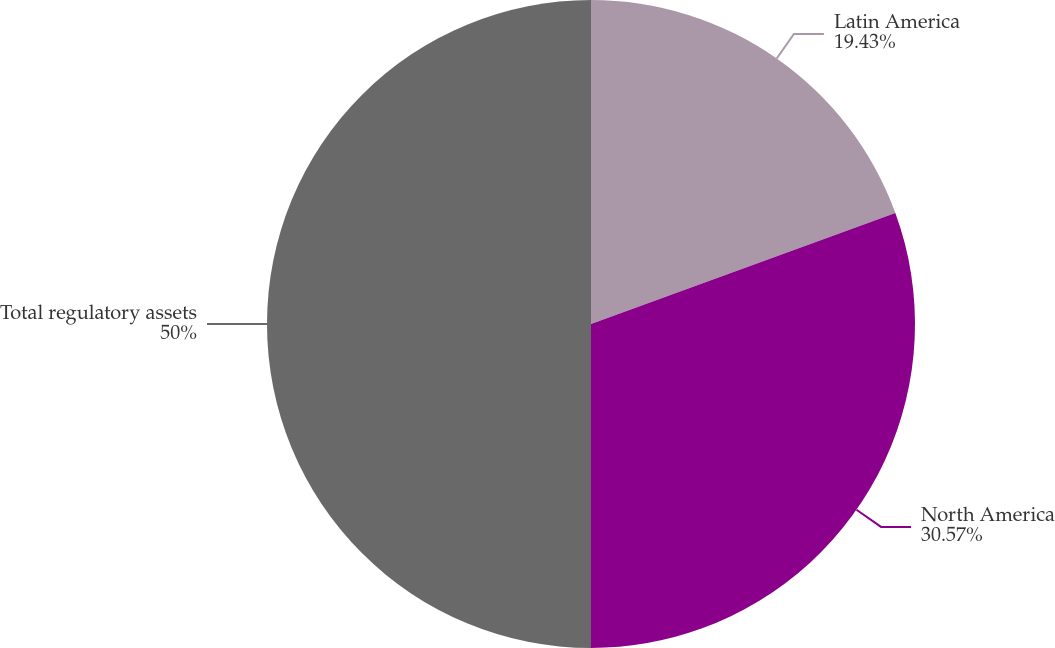Convert chart to OTSL. <chart><loc_0><loc_0><loc_500><loc_500><pie_chart><fcel>Latin America<fcel>North America<fcel>Total regulatory assets<nl><fcel>19.43%<fcel>30.57%<fcel>50.0%<nl></chart> 